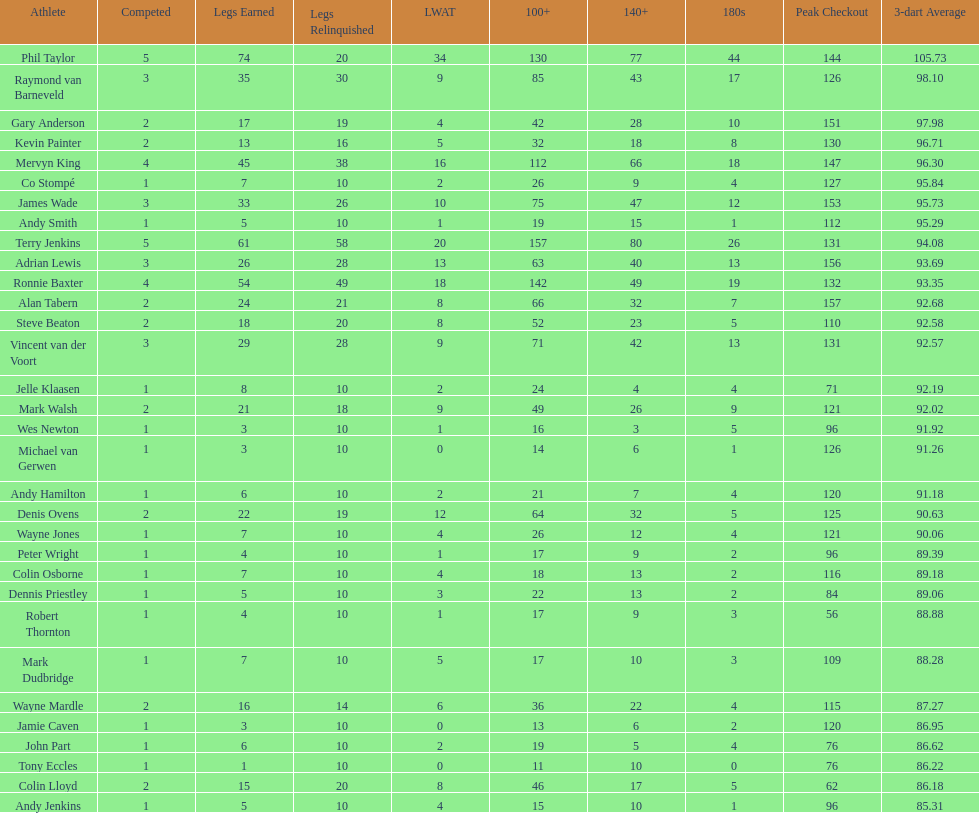Mark walsh's average is above/below 93? Below. 